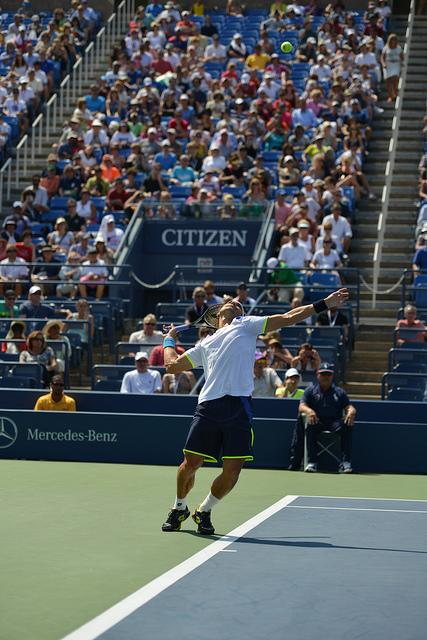What type action is the tennis player here doing? serving 